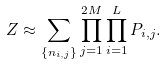Convert formula to latex. <formula><loc_0><loc_0><loc_500><loc_500>Z \approx \sum _ { \{ n _ { i , j } \} } \prod _ { j = 1 } ^ { 2 M } \prod _ { i = 1 } ^ { L } P _ { i , j } .</formula> 